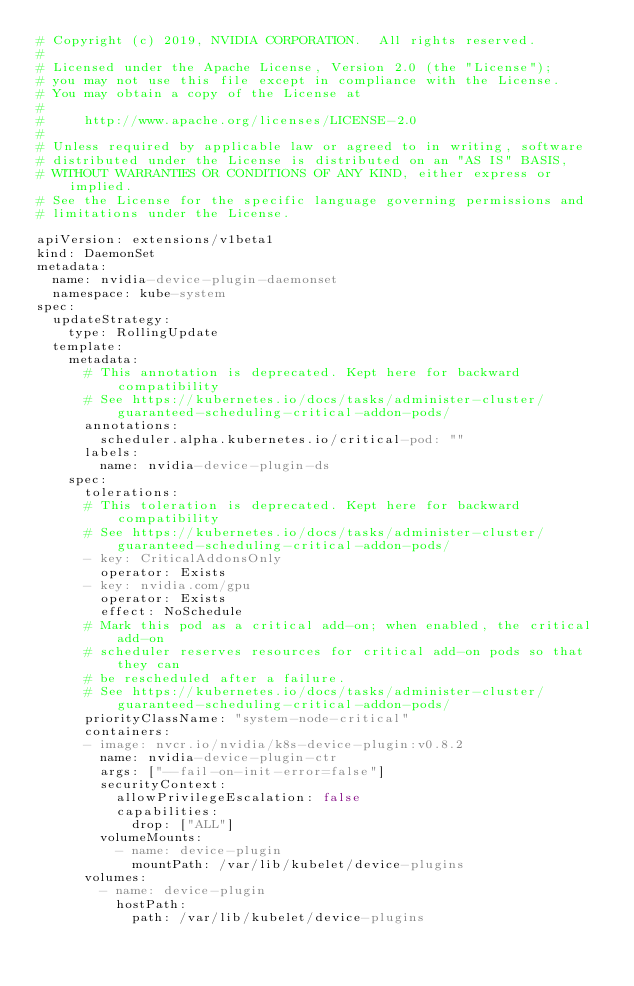<code> <loc_0><loc_0><loc_500><loc_500><_YAML_># Copyright (c) 2019, NVIDIA CORPORATION.  All rights reserved.
#
# Licensed under the Apache License, Version 2.0 (the "License");
# you may not use this file except in compliance with the License.
# You may obtain a copy of the License at
#
#     http://www.apache.org/licenses/LICENSE-2.0
#
# Unless required by applicable law or agreed to in writing, software
# distributed under the License is distributed on an "AS IS" BASIS,
# WITHOUT WARRANTIES OR CONDITIONS OF ANY KIND, either express or implied.
# See the License for the specific language governing permissions and
# limitations under the License.

apiVersion: extensions/v1beta1
kind: DaemonSet
metadata:
  name: nvidia-device-plugin-daemonset
  namespace: kube-system
spec:
  updateStrategy:
    type: RollingUpdate
  template:
    metadata:
      # This annotation is deprecated. Kept here for backward compatibility
      # See https://kubernetes.io/docs/tasks/administer-cluster/guaranteed-scheduling-critical-addon-pods/
      annotations:
        scheduler.alpha.kubernetes.io/critical-pod: ""
      labels:
        name: nvidia-device-plugin-ds
    spec:
      tolerations:
      # This toleration is deprecated. Kept here for backward compatibility
      # See https://kubernetes.io/docs/tasks/administer-cluster/guaranteed-scheduling-critical-addon-pods/
      - key: CriticalAddonsOnly
        operator: Exists
      - key: nvidia.com/gpu
        operator: Exists
        effect: NoSchedule
      # Mark this pod as a critical add-on; when enabled, the critical add-on
      # scheduler reserves resources for critical add-on pods so that they can
      # be rescheduled after a failure.
      # See https://kubernetes.io/docs/tasks/administer-cluster/guaranteed-scheduling-critical-addon-pods/
      priorityClassName: "system-node-critical"
      containers:
      - image: nvcr.io/nvidia/k8s-device-plugin:v0.8.2
        name: nvidia-device-plugin-ctr
        args: ["--fail-on-init-error=false"]
        securityContext:
          allowPrivilegeEscalation: false
          capabilities:
            drop: ["ALL"]
        volumeMounts:
          - name: device-plugin
            mountPath: /var/lib/kubelet/device-plugins
      volumes:
        - name: device-plugin
          hostPath:
            path: /var/lib/kubelet/device-plugins
</code> 